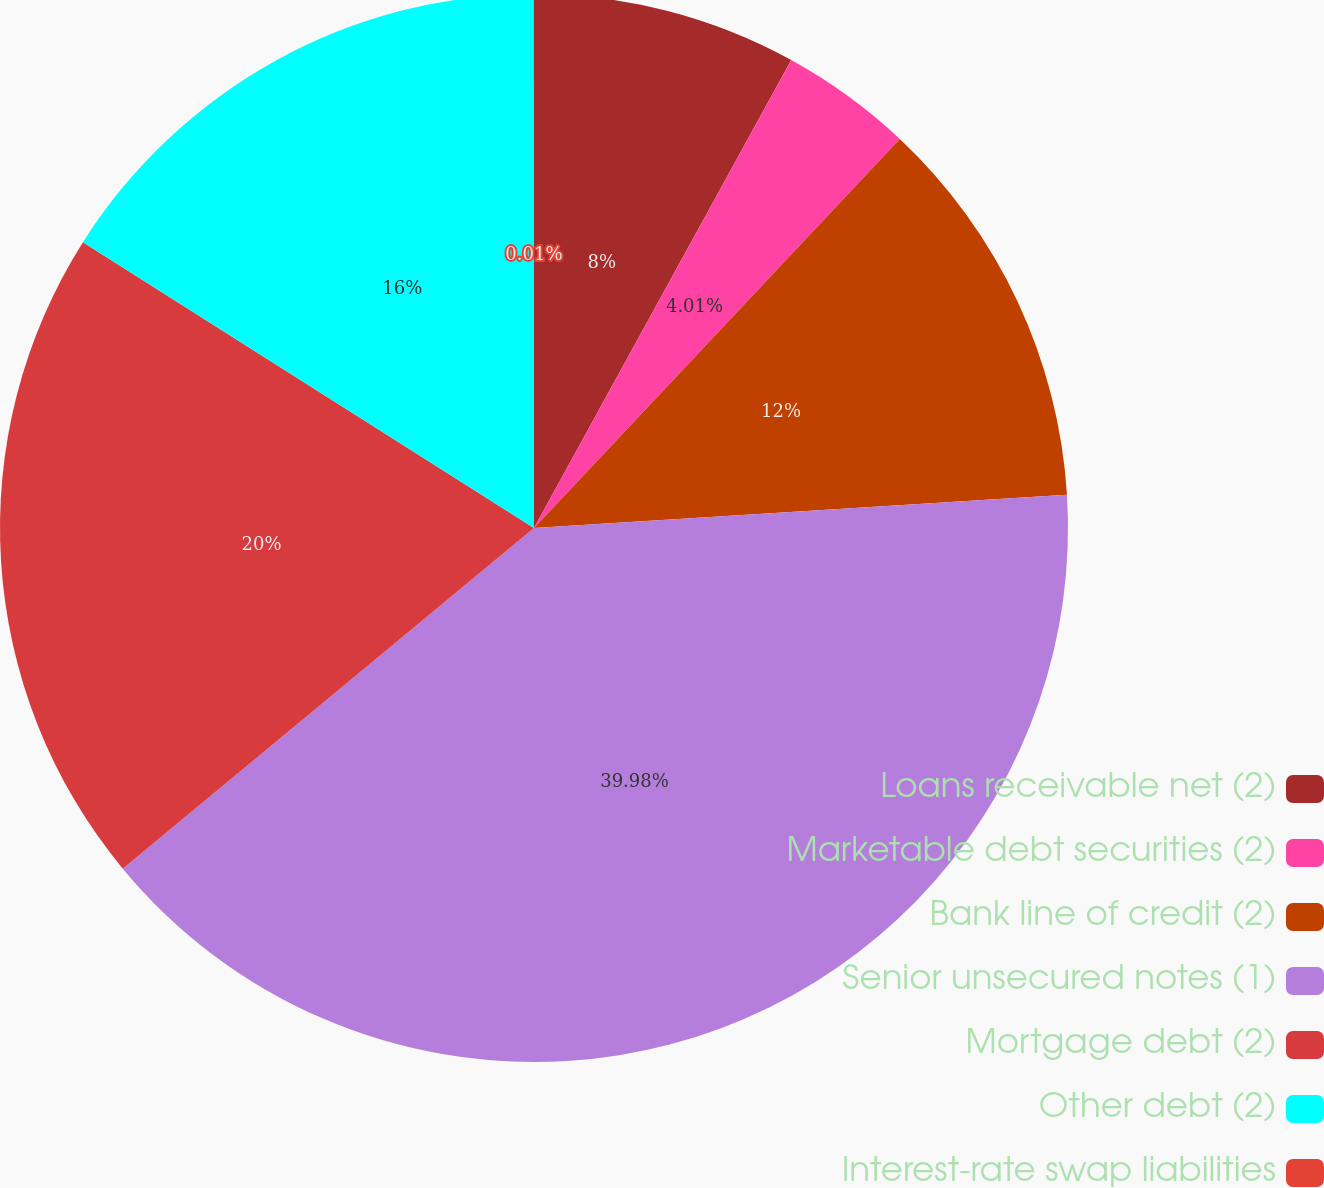<chart> <loc_0><loc_0><loc_500><loc_500><pie_chart><fcel>Loans receivable net (2)<fcel>Marketable debt securities (2)<fcel>Bank line of credit (2)<fcel>Senior unsecured notes (1)<fcel>Mortgage debt (2)<fcel>Other debt (2)<fcel>Interest-rate swap liabilities<nl><fcel>8.0%<fcel>4.01%<fcel>12.0%<fcel>39.98%<fcel>20.0%<fcel>16.0%<fcel>0.01%<nl></chart> 